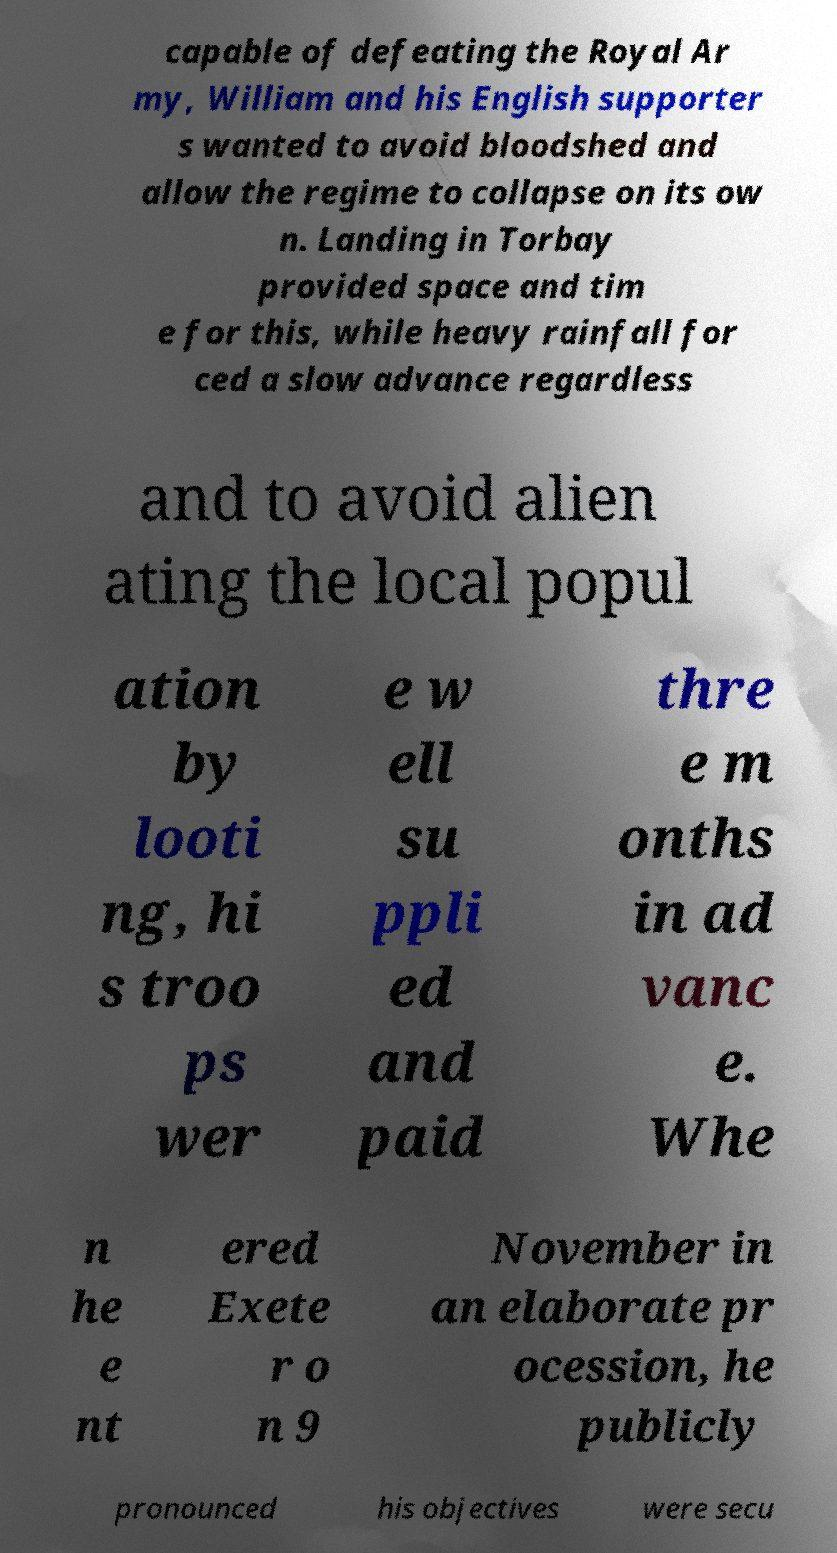There's text embedded in this image that I need extracted. Can you transcribe it verbatim? capable of defeating the Royal Ar my, William and his English supporter s wanted to avoid bloodshed and allow the regime to collapse on its ow n. Landing in Torbay provided space and tim e for this, while heavy rainfall for ced a slow advance regardless and to avoid alien ating the local popul ation by looti ng, hi s troo ps wer e w ell su ppli ed and paid thre e m onths in ad vanc e. Whe n he e nt ered Exete r o n 9 November in an elaborate pr ocession, he publicly pronounced his objectives were secu 